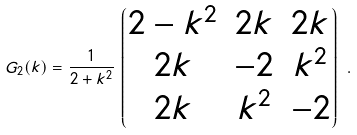<formula> <loc_0><loc_0><loc_500><loc_500>G _ { 2 } ( k ) = \frac { 1 } { 2 + k ^ { 2 } } \left \lgroup \begin{matrix} 2 - k ^ { 2 } & 2 k & 2 k \\ 2 k & - 2 & k ^ { 2 } \\ 2 k & k ^ { 2 } & - 2 \end{matrix} \right \rgroup \, .</formula> 